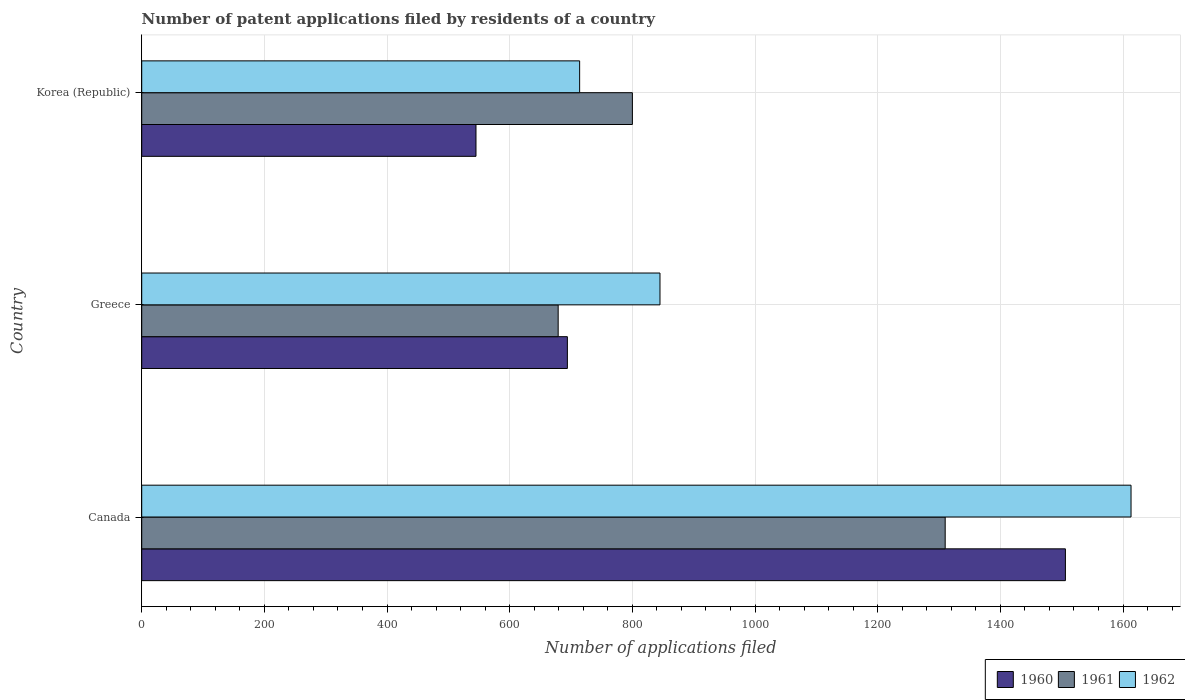How many different coloured bars are there?
Offer a very short reply. 3. Are the number of bars on each tick of the Y-axis equal?
Provide a short and direct response. Yes. How many bars are there on the 1st tick from the top?
Give a very brief answer. 3. How many bars are there on the 1st tick from the bottom?
Your answer should be very brief. 3. What is the label of the 2nd group of bars from the top?
Offer a terse response. Greece. What is the number of applications filed in 1962 in Korea (Republic)?
Your answer should be very brief. 714. Across all countries, what is the maximum number of applications filed in 1960?
Your answer should be very brief. 1506. Across all countries, what is the minimum number of applications filed in 1960?
Your answer should be very brief. 545. In which country was the number of applications filed in 1960 minimum?
Ensure brevity in your answer.  Korea (Republic). What is the total number of applications filed in 1962 in the graph?
Provide a short and direct response. 3172. What is the difference between the number of applications filed in 1961 in Greece and that in Korea (Republic)?
Ensure brevity in your answer.  -121. What is the difference between the number of applications filed in 1962 in Greece and the number of applications filed in 1961 in Korea (Republic)?
Make the answer very short. 45. What is the average number of applications filed in 1961 per country?
Ensure brevity in your answer.  929.67. What is the difference between the number of applications filed in 1961 and number of applications filed in 1960 in Canada?
Ensure brevity in your answer.  -196. What is the ratio of the number of applications filed in 1962 in Greece to that in Korea (Republic)?
Provide a short and direct response. 1.18. Is the difference between the number of applications filed in 1961 in Canada and Korea (Republic) greater than the difference between the number of applications filed in 1960 in Canada and Korea (Republic)?
Provide a succinct answer. No. What is the difference between the highest and the second highest number of applications filed in 1960?
Your response must be concise. 812. What is the difference between the highest and the lowest number of applications filed in 1962?
Make the answer very short. 899. In how many countries, is the number of applications filed in 1960 greater than the average number of applications filed in 1960 taken over all countries?
Provide a short and direct response. 1. What does the 3rd bar from the top in Greece represents?
Ensure brevity in your answer.  1960. How many bars are there?
Provide a succinct answer. 9. How many countries are there in the graph?
Offer a terse response. 3. What is the difference between two consecutive major ticks on the X-axis?
Offer a terse response. 200. Where does the legend appear in the graph?
Keep it short and to the point. Bottom right. How many legend labels are there?
Your response must be concise. 3. How are the legend labels stacked?
Your answer should be very brief. Horizontal. What is the title of the graph?
Give a very brief answer. Number of patent applications filed by residents of a country. What is the label or title of the X-axis?
Provide a succinct answer. Number of applications filed. What is the label or title of the Y-axis?
Your answer should be very brief. Country. What is the Number of applications filed of 1960 in Canada?
Your response must be concise. 1506. What is the Number of applications filed in 1961 in Canada?
Your answer should be compact. 1310. What is the Number of applications filed of 1962 in Canada?
Keep it short and to the point. 1613. What is the Number of applications filed in 1960 in Greece?
Ensure brevity in your answer.  694. What is the Number of applications filed of 1961 in Greece?
Your response must be concise. 679. What is the Number of applications filed of 1962 in Greece?
Give a very brief answer. 845. What is the Number of applications filed of 1960 in Korea (Republic)?
Your response must be concise. 545. What is the Number of applications filed of 1961 in Korea (Republic)?
Make the answer very short. 800. What is the Number of applications filed in 1962 in Korea (Republic)?
Provide a short and direct response. 714. Across all countries, what is the maximum Number of applications filed of 1960?
Keep it short and to the point. 1506. Across all countries, what is the maximum Number of applications filed of 1961?
Offer a very short reply. 1310. Across all countries, what is the maximum Number of applications filed in 1962?
Offer a very short reply. 1613. Across all countries, what is the minimum Number of applications filed of 1960?
Make the answer very short. 545. Across all countries, what is the minimum Number of applications filed of 1961?
Provide a succinct answer. 679. Across all countries, what is the minimum Number of applications filed in 1962?
Offer a very short reply. 714. What is the total Number of applications filed in 1960 in the graph?
Provide a short and direct response. 2745. What is the total Number of applications filed of 1961 in the graph?
Your response must be concise. 2789. What is the total Number of applications filed in 1962 in the graph?
Make the answer very short. 3172. What is the difference between the Number of applications filed in 1960 in Canada and that in Greece?
Provide a succinct answer. 812. What is the difference between the Number of applications filed of 1961 in Canada and that in Greece?
Offer a very short reply. 631. What is the difference between the Number of applications filed of 1962 in Canada and that in Greece?
Keep it short and to the point. 768. What is the difference between the Number of applications filed of 1960 in Canada and that in Korea (Republic)?
Your answer should be compact. 961. What is the difference between the Number of applications filed of 1961 in Canada and that in Korea (Republic)?
Provide a succinct answer. 510. What is the difference between the Number of applications filed in 1962 in Canada and that in Korea (Republic)?
Your answer should be very brief. 899. What is the difference between the Number of applications filed of 1960 in Greece and that in Korea (Republic)?
Ensure brevity in your answer.  149. What is the difference between the Number of applications filed in 1961 in Greece and that in Korea (Republic)?
Your answer should be very brief. -121. What is the difference between the Number of applications filed in 1962 in Greece and that in Korea (Republic)?
Make the answer very short. 131. What is the difference between the Number of applications filed in 1960 in Canada and the Number of applications filed in 1961 in Greece?
Provide a succinct answer. 827. What is the difference between the Number of applications filed in 1960 in Canada and the Number of applications filed in 1962 in Greece?
Offer a very short reply. 661. What is the difference between the Number of applications filed in 1961 in Canada and the Number of applications filed in 1962 in Greece?
Offer a terse response. 465. What is the difference between the Number of applications filed in 1960 in Canada and the Number of applications filed in 1961 in Korea (Republic)?
Offer a terse response. 706. What is the difference between the Number of applications filed in 1960 in Canada and the Number of applications filed in 1962 in Korea (Republic)?
Give a very brief answer. 792. What is the difference between the Number of applications filed in 1961 in Canada and the Number of applications filed in 1962 in Korea (Republic)?
Your response must be concise. 596. What is the difference between the Number of applications filed in 1960 in Greece and the Number of applications filed in 1961 in Korea (Republic)?
Your answer should be very brief. -106. What is the difference between the Number of applications filed in 1960 in Greece and the Number of applications filed in 1962 in Korea (Republic)?
Your answer should be compact. -20. What is the difference between the Number of applications filed in 1961 in Greece and the Number of applications filed in 1962 in Korea (Republic)?
Make the answer very short. -35. What is the average Number of applications filed of 1960 per country?
Your answer should be compact. 915. What is the average Number of applications filed of 1961 per country?
Ensure brevity in your answer.  929.67. What is the average Number of applications filed of 1962 per country?
Provide a short and direct response. 1057.33. What is the difference between the Number of applications filed of 1960 and Number of applications filed of 1961 in Canada?
Provide a short and direct response. 196. What is the difference between the Number of applications filed of 1960 and Number of applications filed of 1962 in Canada?
Provide a succinct answer. -107. What is the difference between the Number of applications filed in 1961 and Number of applications filed in 1962 in Canada?
Offer a terse response. -303. What is the difference between the Number of applications filed of 1960 and Number of applications filed of 1962 in Greece?
Provide a short and direct response. -151. What is the difference between the Number of applications filed in 1961 and Number of applications filed in 1962 in Greece?
Provide a succinct answer. -166. What is the difference between the Number of applications filed of 1960 and Number of applications filed of 1961 in Korea (Republic)?
Provide a succinct answer. -255. What is the difference between the Number of applications filed in 1960 and Number of applications filed in 1962 in Korea (Republic)?
Provide a succinct answer. -169. What is the difference between the Number of applications filed of 1961 and Number of applications filed of 1962 in Korea (Republic)?
Offer a terse response. 86. What is the ratio of the Number of applications filed in 1960 in Canada to that in Greece?
Keep it short and to the point. 2.17. What is the ratio of the Number of applications filed in 1961 in Canada to that in Greece?
Give a very brief answer. 1.93. What is the ratio of the Number of applications filed of 1962 in Canada to that in Greece?
Your response must be concise. 1.91. What is the ratio of the Number of applications filed of 1960 in Canada to that in Korea (Republic)?
Your response must be concise. 2.76. What is the ratio of the Number of applications filed in 1961 in Canada to that in Korea (Republic)?
Your answer should be compact. 1.64. What is the ratio of the Number of applications filed in 1962 in Canada to that in Korea (Republic)?
Offer a terse response. 2.26. What is the ratio of the Number of applications filed of 1960 in Greece to that in Korea (Republic)?
Give a very brief answer. 1.27. What is the ratio of the Number of applications filed of 1961 in Greece to that in Korea (Republic)?
Your answer should be very brief. 0.85. What is the ratio of the Number of applications filed in 1962 in Greece to that in Korea (Republic)?
Provide a short and direct response. 1.18. What is the difference between the highest and the second highest Number of applications filed in 1960?
Provide a succinct answer. 812. What is the difference between the highest and the second highest Number of applications filed of 1961?
Give a very brief answer. 510. What is the difference between the highest and the second highest Number of applications filed in 1962?
Make the answer very short. 768. What is the difference between the highest and the lowest Number of applications filed of 1960?
Ensure brevity in your answer.  961. What is the difference between the highest and the lowest Number of applications filed of 1961?
Your answer should be very brief. 631. What is the difference between the highest and the lowest Number of applications filed of 1962?
Offer a very short reply. 899. 